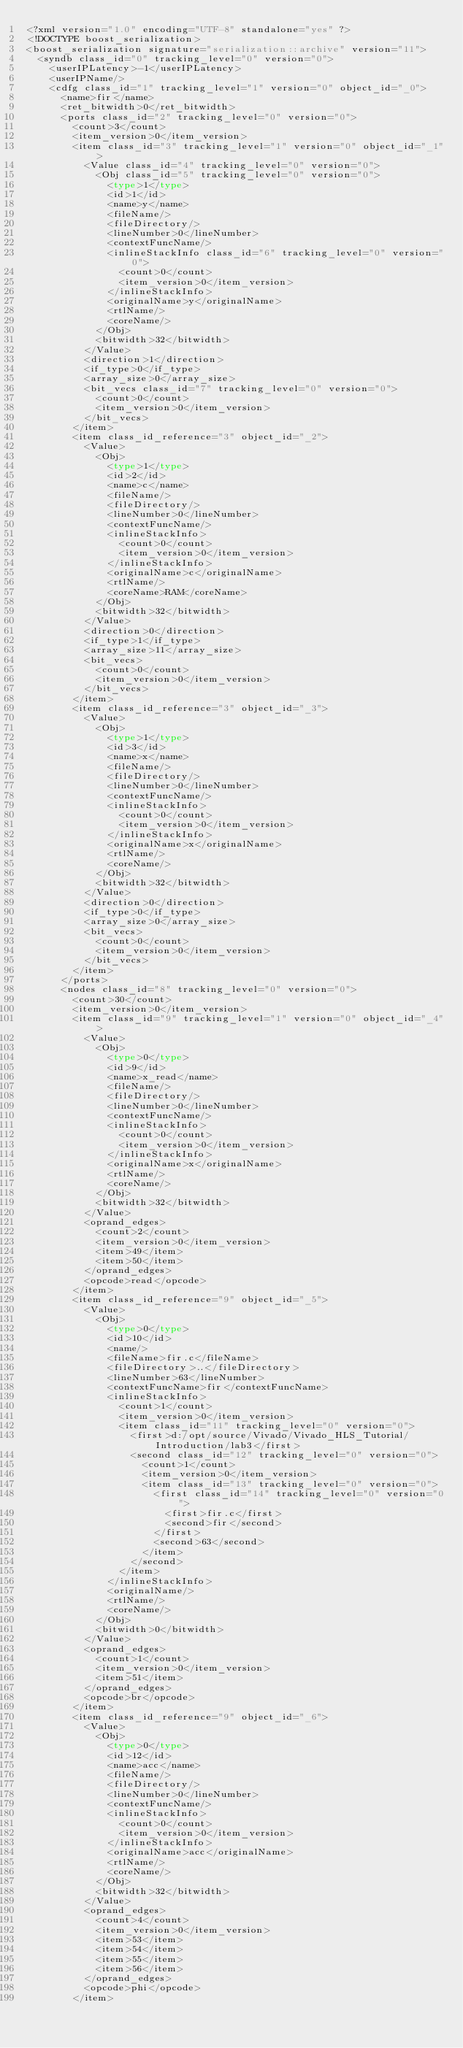<code> <loc_0><loc_0><loc_500><loc_500><_Ada_><?xml version="1.0" encoding="UTF-8" standalone="yes" ?>
<!DOCTYPE boost_serialization>
<boost_serialization signature="serialization::archive" version="11">
  <syndb class_id="0" tracking_level="0" version="0">
    <userIPLatency>-1</userIPLatency>
    <userIPName/>
    <cdfg class_id="1" tracking_level="1" version="0" object_id="_0">
      <name>fir</name>
      <ret_bitwidth>0</ret_bitwidth>
      <ports class_id="2" tracking_level="0" version="0">
        <count>3</count>
        <item_version>0</item_version>
        <item class_id="3" tracking_level="1" version="0" object_id="_1">
          <Value class_id="4" tracking_level="0" version="0">
            <Obj class_id="5" tracking_level="0" version="0">
              <type>1</type>
              <id>1</id>
              <name>y</name>
              <fileName/>
              <fileDirectory/>
              <lineNumber>0</lineNumber>
              <contextFuncName/>
              <inlineStackInfo class_id="6" tracking_level="0" version="0">
                <count>0</count>
                <item_version>0</item_version>
              </inlineStackInfo>
              <originalName>y</originalName>
              <rtlName/>
              <coreName/>
            </Obj>
            <bitwidth>32</bitwidth>
          </Value>
          <direction>1</direction>
          <if_type>0</if_type>
          <array_size>0</array_size>
          <bit_vecs class_id="7" tracking_level="0" version="0">
            <count>0</count>
            <item_version>0</item_version>
          </bit_vecs>
        </item>
        <item class_id_reference="3" object_id="_2">
          <Value>
            <Obj>
              <type>1</type>
              <id>2</id>
              <name>c</name>
              <fileName/>
              <fileDirectory/>
              <lineNumber>0</lineNumber>
              <contextFuncName/>
              <inlineStackInfo>
                <count>0</count>
                <item_version>0</item_version>
              </inlineStackInfo>
              <originalName>c</originalName>
              <rtlName/>
              <coreName>RAM</coreName>
            </Obj>
            <bitwidth>32</bitwidth>
          </Value>
          <direction>0</direction>
          <if_type>1</if_type>
          <array_size>11</array_size>
          <bit_vecs>
            <count>0</count>
            <item_version>0</item_version>
          </bit_vecs>
        </item>
        <item class_id_reference="3" object_id="_3">
          <Value>
            <Obj>
              <type>1</type>
              <id>3</id>
              <name>x</name>
              <fileName/>
              <fileDirectory/>
              <lineNumber>0</lineNumber>
              <contextFuncName/>
              <inlineStackInfo>
                <count>0</count>
                <item_version>0</item_version>
              </inlineStackInfo>
              <originalName>x</originalName>
              <rtlName/>
              <coreName/>
            </Obj>
            <bitwidth>32</bitwidth>
          </Value>
          <direction>0</direction>
          <if_type>0</if_type>
          <array_size>0</array_size>
          <bit_vecs>
            <count>0</count>
            <item_version>0</item_version>
          </bit_vecs>
        </item>
      </ports>
      <nodes class_id="8" tracking_level="0" version="0">
        <count>30</count>
        <item_version>0</item_version>
        <item class_id="9" tracking_level="1" version="0" object_id="_4">
          <Value>
            <Obj>
              <type>0</type>
              <id>9</id>
              <name>x_read</name>
              <fileName/>
              <fileDirectory/>
              <lineNumber>0</lineNumber>
              <contextFuncName/>
              <inlineStackInfo>
                <count>0</count>
                <item_version>0</item_version>
              </inlineStackInfo>
              <originalName>x</originalName>
              <rtlName/>
              <coreName/>
            </Obj>
            <bitwidth>32</bitwidth>
          </Value>
          <oprand_edges>
            <count>2</count>
            <item_version>0</item_version>
            <item>49</item>
            <item>50</item>
          </oprand_edges>
          <opcode>read</opcode>
        </item>
        <item class_id_reference="9" object_id="_5">
          <Value>
            <Obj>
              <type>0</type>
              <id>10</id>
              <name/>
              <fileName>fir.c</fileName>
              <fileDirectory>..</fileDirectory>
              <lineNumber>63</lineNumber>
              <contextFuncName>fir</contextFuncName>
              <inlineStackInfo>
                <count>1</count>
                <item_version>0</item_version>
                <item class_id="11" tracking_level="0" version="0">
                  <first>d:/opt/source/Vivado/Vivado_HLS_Tutorial/Introduction/lab3</first>
                  <second class_id="12" tracking_level="0" version="0">
                    <count>1</count>
                    <item_version>0</item_version>
                    <item class_id="13" tracking_level="0" version="0">
                      <first class_id="14" tracking_level="0" version="0">
                        <first>fir.c</first>
                        <second>fir</second>
                      </first>
                      <second>63</second>
                    </item>
                  </second>
                </item>
              </inlineStackInfo>
              <originalName/>
              <rtlName/>
              <coreName/>
            </Obj>
            <bitwidth>0</bitwidth>
          </Value>
          <oprand_edges>
            <count>1</count>
            <item_version>0</item_version>
            <item>51</item>
          </oprand_edges>
          <opcode>br</opcode>
        </item>
        <item class_id_reference="9" object_id="_6">
          <Value>
            <Obj>
              <type>0</type>
              <id>12</id>
              <name>acc</name>
              <fileName/>
              <fileDirectory/>
              <lineNumber>0</lineNumber>
              <contextFuncName/>
              <inlineStackInfo>
                <count>0</count>
                <item_version>0</item_version>
              </inlineStackInfo>
              <originalName>acc</originalName>
              <rtlName/>
              <coreName/>
            </Obj>
            <bitwidth>32</bitwidth>
          </Value>
          <oprand_edges>
            <count>4</count>
            <item_version>0</item_version>
            <item>53</item>
            <item>54</item>
            <item>55</item>
            <item>56</item>
          </oprand_edges>
          <opcode>phi</opcode>
        </item></code> 